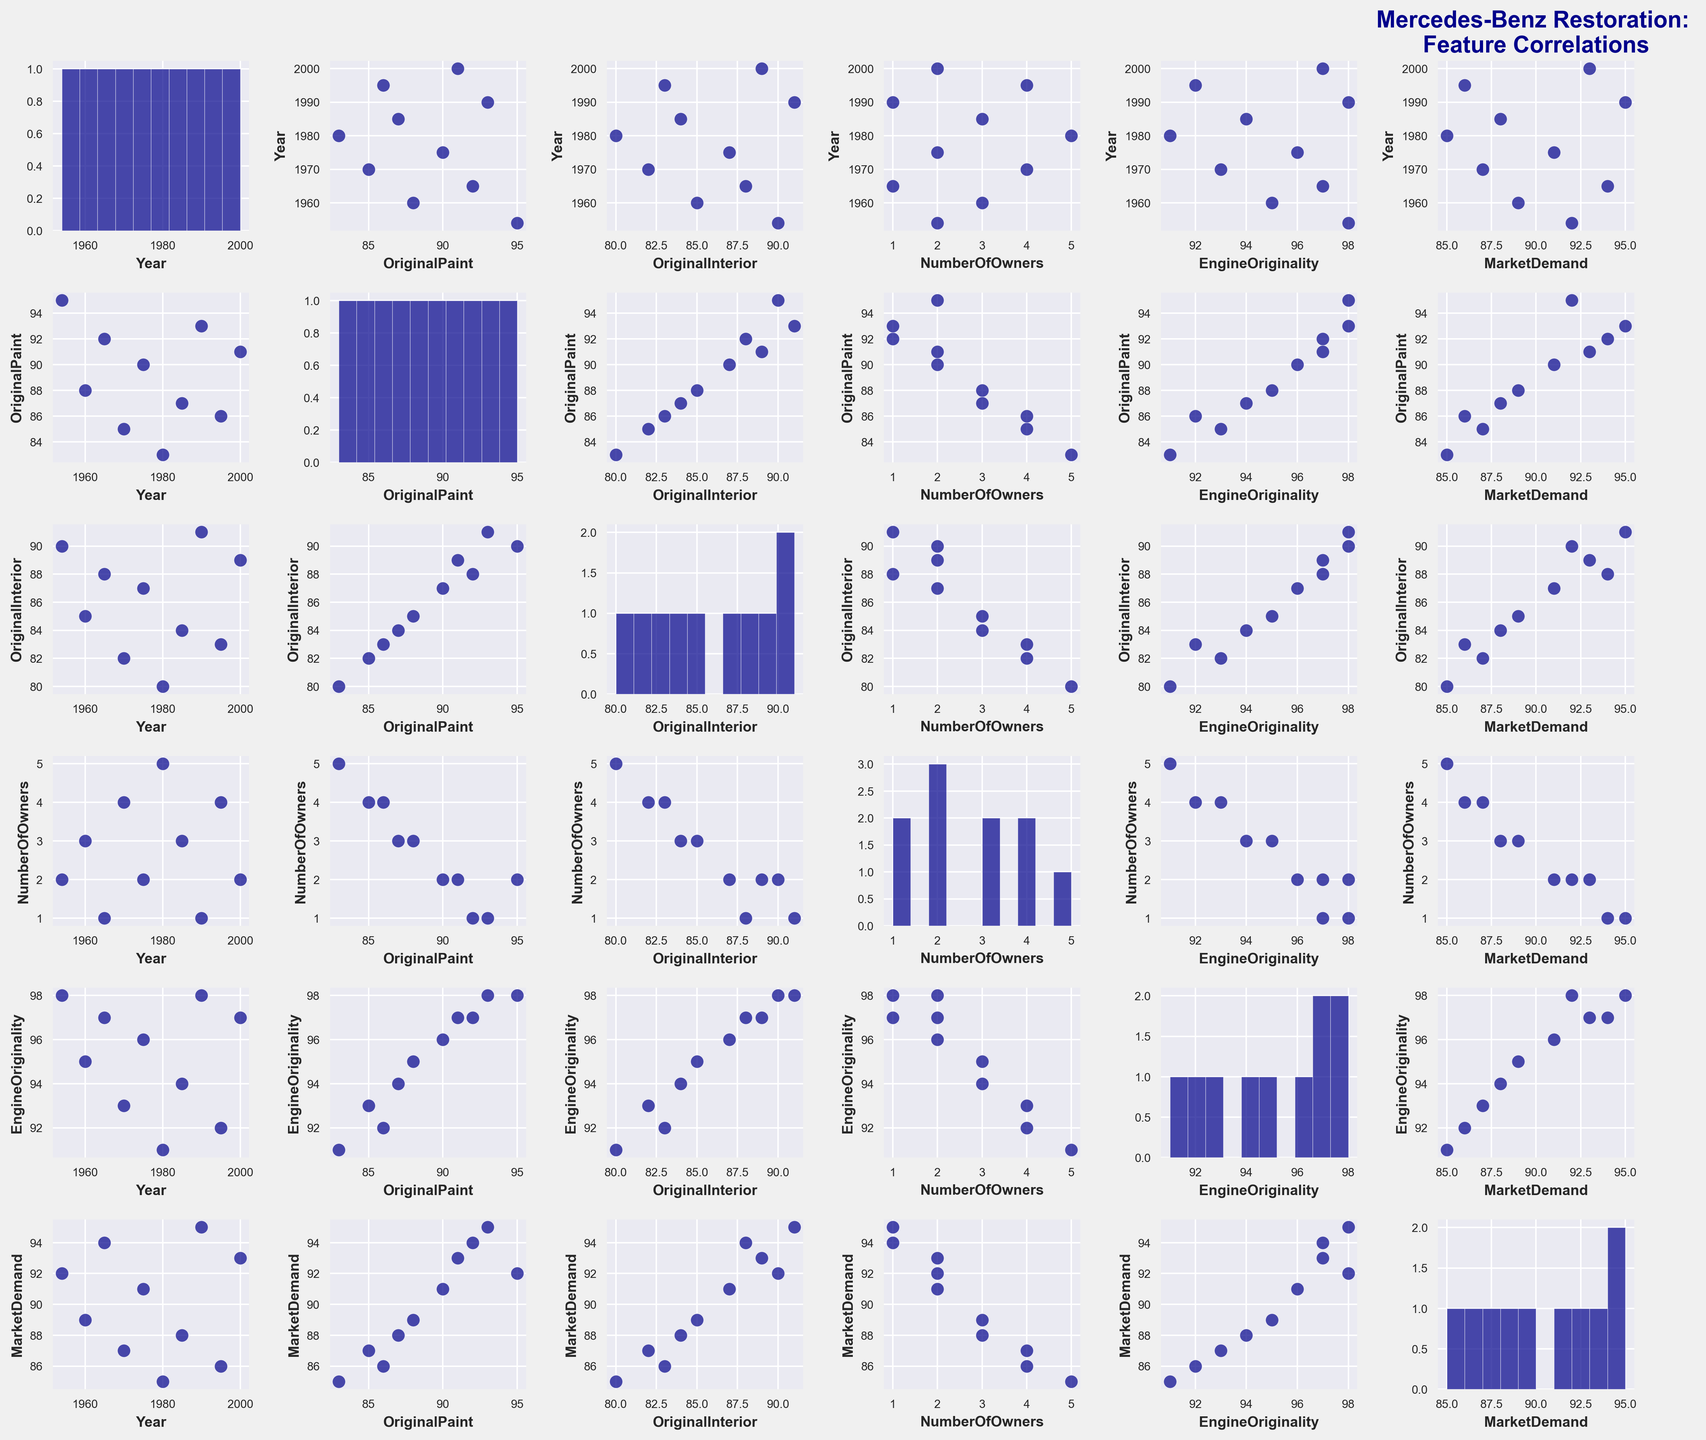What is the title of the scatterplot matrix? The title is usually prominently displayed at the top of the figure and often explains the overall context of the visual. In this case, it should be located at the upper part of the figure.
Answer: Mercedes-Benz Restoration: Feature Correlations How many features are being compared in the scatterplot matrix? The scatterplot matrix compares each feature with every other feature, as shown in the grid. The number of unique features can be counted by observing the labels on the diagonal cells of the matrix.
Answer: 6 What is the relationship between Market Demand and Year? This can be observed by looking at the scatterplot where Market Demand and Year are being compared. By identifying the trend in the data points arrangement, we can infer if there is a positive, negative, or no correlation.
Answer: Positive correlation Is there a strong correlation between Original Paint and Engine Originality? By examining the scatterplot where Original Paint is on one axis and Engine Originality on the other, we can see if the data points form a clear trend. The strength of the correlation is generally indicated by how closely the points follow a line.
Answer: Yes Which feature pair has the most scattered data points visually suggesting the weakest correlation? By systematically examining each scatterplot in the matrix, one can identify which pair has data points that appear most spread out and do not follow any specific pattern, indicating a weak correlation.
Answer: Number of Owners vs Engine Originality What can you infer from the histogram of Market Demand? The histogram provides a visual representation of the frequency distribution of Market Demand. Observing the spread and concentration of bars can suggest the common values and the range.
Answer: Most values are clustered around 90-95 Are there more vehicles with Engine Originality rated at 95 or above compared to those rated below 95? By referring to the scatterplots that involve Engine Originality, we can count how many points fall above 95 and compare with those below 95. Observing trends across different scatterplots in the matrix confirms this count.
Answer: Yes Between Original Paint and Market Demand, which tends to have higher values based on their scatterplot? By examining the scatterplot where Original Paint is compared with Market Demand, one can observe and compare the positions of the data points relative to each axis.
Answer: Market Demand Does the scatterplot matrix show any apparent relationship between the Number of Owners and Market Demand? The relevant scatterplot can be checked for any discernible pattern or trend in the distribution of data points. If points are more scattered with no clear pattern, the relationship is weak or none.
Answer: Weak or none How does the variation in Original Interior compare to that of Year based on their histograms? By examining each histogram for Original Interior and Year, one can compare the spread (range of values) and concentration of frequency bars to understand how the variability in these two features differs.
Answer: Original Interior has less variation 